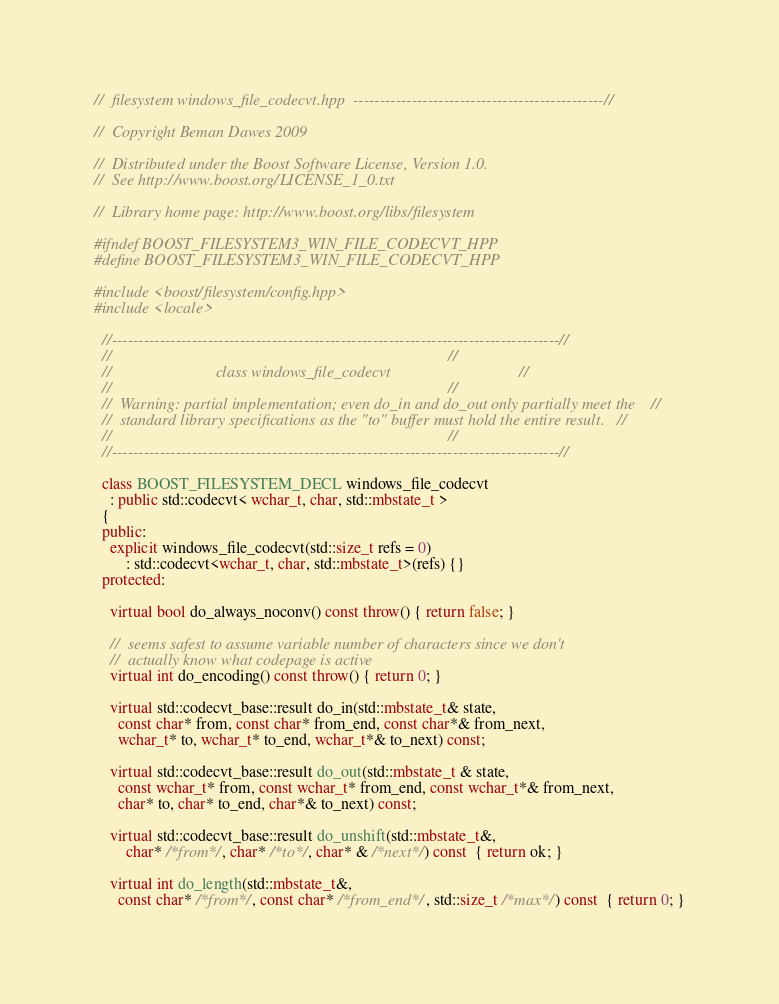<code> <loc_0><loc_0><loc_500><loc_500><_C++_>//  filesystem windows_file_codecvt.hpp  -----------------------------------------------//

//  Copyright Beman Dawes 2009

//  Distributed under the Boost Software License, Version 1.0.
//  See http://www.boost.org/LICENSE_1_0.txt

//  Library home page: http://www.boost.org/libs/filesystem

#ifndef BOOST_FILESYSTEM3_WIN_FILE_CODECVT_HPP
#define BOOST_FILESYSTEM3_WIN_FILE_CODECVT_HPP

#include <boost/filesystem/config.hpp>
#include <locale>  

  //------------------------------------------------------------------------------------//
  //                                                                                    //
  //                          class windows_file_codecvt                                //
  //                                                                                    //
  //  Warning: partial implementation; even do_in and do_out only partially meet the    //
  //  standard library specifications as the "to" buffer must hold the entire result.   //
  //                                                                                    //
  //------------------------------------------------------------------------------------//

  class BOOST_FILESYSTEM_DECL windows_file_codecvt
    : public std::codecvt< wchar_t, char, std::mbstate_t >  
  {
  public:
    explicit windows_file_codecvt(std::size_t refs = 0)
        : std::codecvt<wchar_t, char, std::mbstate_t>(refs) {}
  protected:

    virtual bool do_always_noconv() const throw() { return false; }

    //  seems safest to assume variable number of characters since we don't
    //  actually know what codepage is active
    virtual int do_encoding() const throw() { return 0; }

    virtual std::codecvt_base::result do_in(std::mbstate_t& state, 
      const char* from, const char* from_end, const char*& from_next,
      wchar_t* to, wchar_t* to_end, wchar_t*& to_next) const;

    virtual std::codecvt_base::result do_out(std::mbstate_t & state,
      const wchar_t* from, const wchar_t* from_end, const wchar_t*& from_next,
      char* to, char* to_end, char*& to_next) const;

    virtual std::codecvt_base::result do_unshift(std::mbstate_t&,
        char* /*from*/, char* /*to*/, char* & /*next*/) const  { return ok; } 

    virtual int do_length(std::mbstate_t&,
      const char* /*from*/, const char* /*from_end*/, std::size_t /*max*/) const  { return 0; }
</code> 